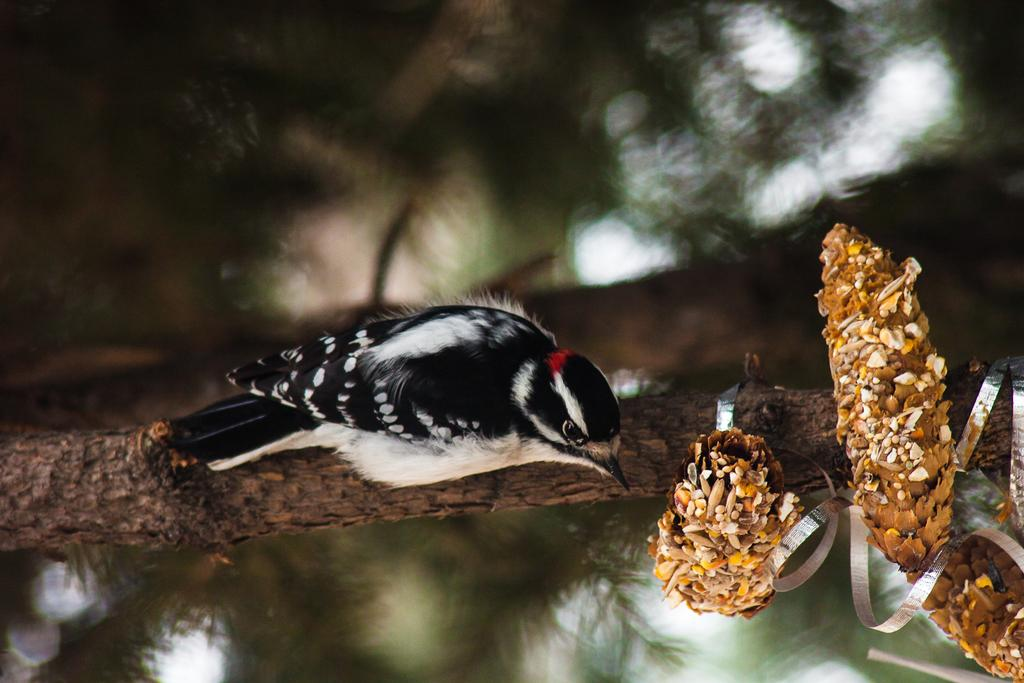What type of animal can be seen in the image? There is a bird in the image. Where is the bird located in the image? The bird is on a stem. What color scheme is used for the bird in the image? The bird is in black and white colors. What can be seen on the right side of the image? There are flowers on the right side of the image. How would you describe the background of the image? The background of the image is blurred. Can you tell me how many mittens are being used by the bird in the image? There are no mittens present in the image; the bird is in black and white colors and is on a stem. Is there a baseball game happening in the background of the image? There is no baseball game or any reference to baseball in the image; it features a bird on a stem with flowers on the right side and a blurred background. 